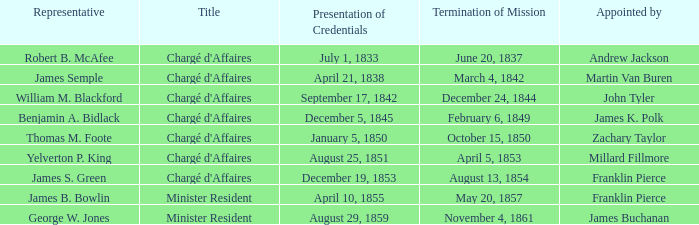Which title has a designated by of millard fillmore? Chargé d'Affaires. 